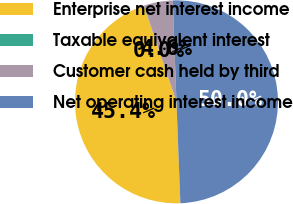Convert chart to OTSL. <chart><loc_0><loc_0><loc_500><loc_500><pie_chart><fcel>Enterprise net interest income<fcel>Taxable equivalent interest<fcel>Customer cash held by third<fcel>Net operating interest income<nl><fcel>45.39%<fcel>0.04%<fcel>4.61%<fcel>49.96%<nl></chart> 